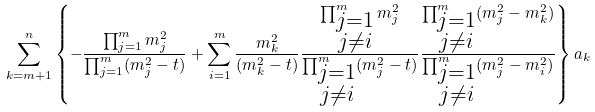<formula> <loc_0><loc_0><loc_500><loc_500>\sum _ { k = m + 1 } ^ { n } \left \{ - \frac { \prod _ { j = 1 } ^ { m } m _ { j } ^ { 2 } } { \prod _ { j = 1 } ^ { m } ( m _ { j } ^ { 2 } - t ) } + \sum _ { i = 1 } ^ { m } \frac { m _ { k } ^ { 2 } } { ( m _ { k } ^ { 2 } - t ) } \frac { \prod _ { \substack { j = 1 \\ j \neq i } } ^ { m } m _ { j } ^ { 2 } } { \prod ^ { m } _ { \substack { j = 1 \\ j \neq i } } ( m _ { j } ^ { 2 } - t ) } \frac { \prod ^ { m } _ { \substack { j = 1 \\ j \neq i } } ( m _ { j } ^ { 2 } - m _ { k } ^ { 2 } ) } { \prod ^ { m } _ { \substack { j = 1 \\ j \neq i } } ( m _ { j } ^ { 2 } - m _ { i } ^ { 2 } ) } \right \} a _ { k }</formula> 